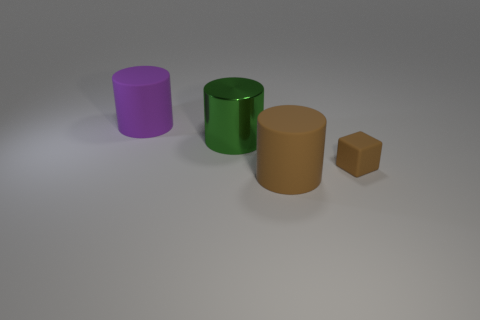Are there any other things that are the same shape as the tiny brown matte thing?
Your response must be concise. No. How many objects are either objects in front of the purple cylinder or purple things?
Ensure brevity in your answer.  4. There is a small matte thing; is it the same color as the big rubber thing that is in front of the small brown rubber block?
Provide a succinct answer. Yes. Is there a brown rubber cylinder of the same size as the metal cylinder?
Give a very brief answer. Yes. The green cylinder that is left of the rubber thing in front of the tiny brown object is made of what material?
Ensure brevity in your answer.  Metal. What number of big matte cylinders are the same color as the tiny object?
Provide a short and direct response. 1. There is a large brown object that is the same material as the tiny brown object; what shape is it?
Your answer should be compact. Cylinder. What size is the matte cylinder left of the green metallic cylinder?
Provide a succinct answer. Large. Are there an equal number of matte cylinders that are to the right of the brown rubber block and brown matte things that are behind the large brown cylinder?
Give a very brief answer. No. There is a big rubber cylinder behind the matte cylinder that is in front of the matte cylinder that is behind the tiny rubber cube; what color is it?
Your answer should be compact. Purple. 